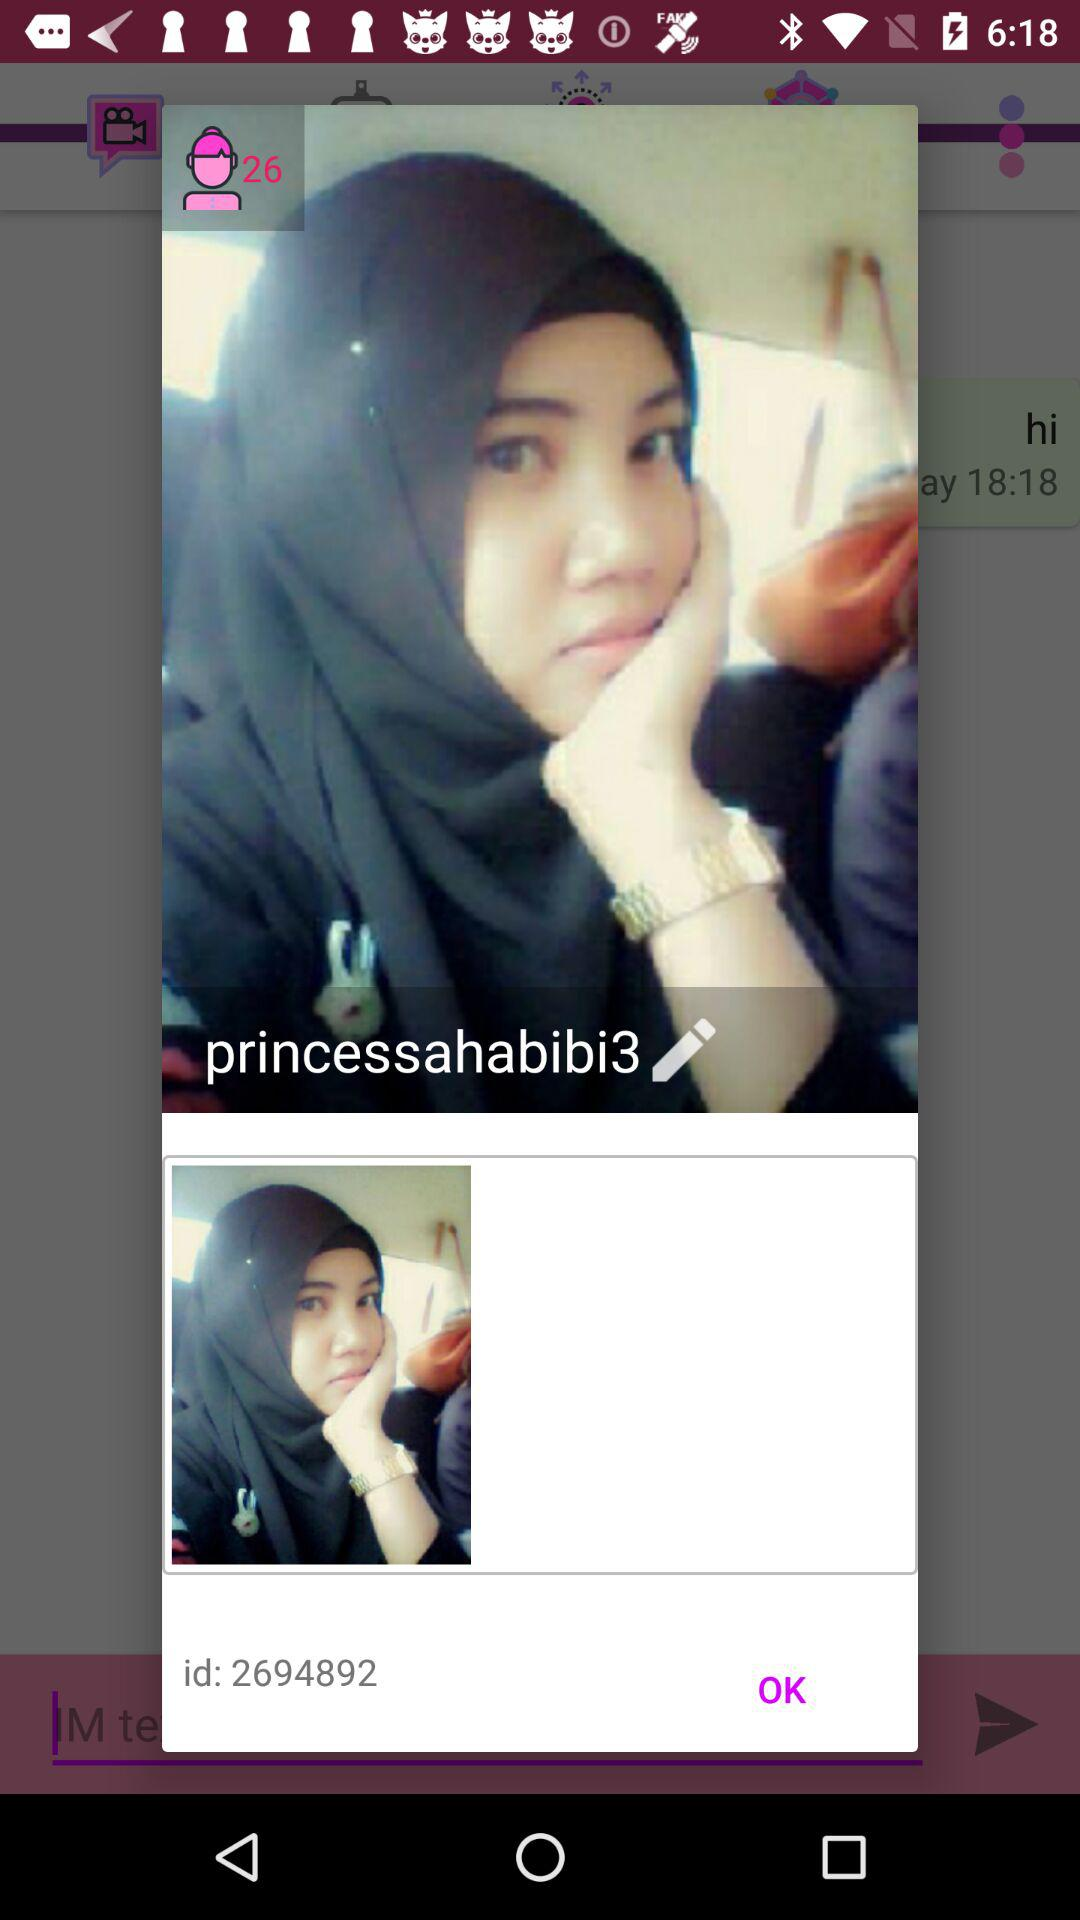What is the age? The age is 26. 